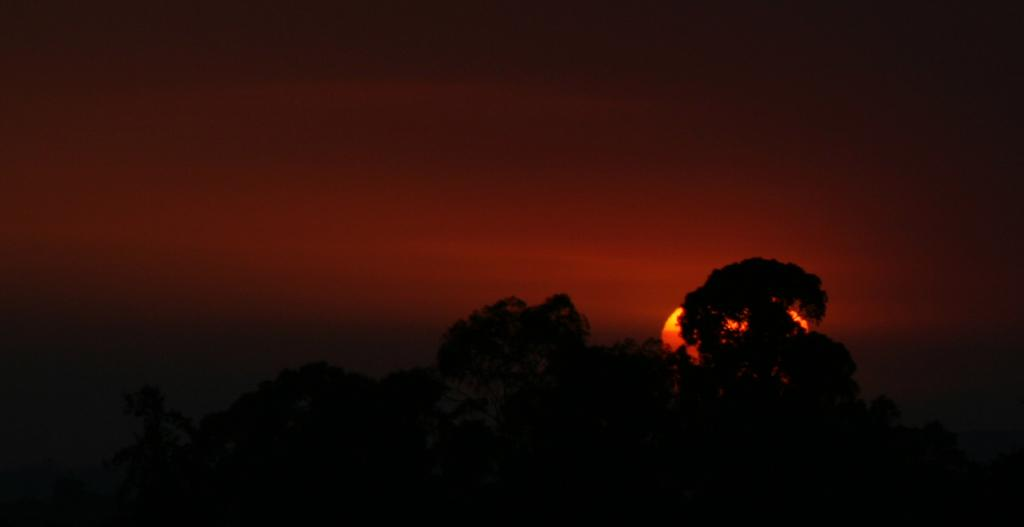What type of vegetation can be seen in the image? There are trees in the image. What celestial body is visible in the image? The sun is visible in the image. What part of the natural environment is depicted in the image? The sky is present in the image. What type of nut can be seen in the jar in the image? There is no jar or nut present in the image. What type of structure can be seen in the image? There is no structure present in the image; it features trees, the sun, and the sky. 